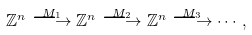<formula> <loc_0><loc_0><loc_500><loc_500>\mathbb { Z } ^ { n } \overset { M _ { 1 } } { \longrightarrow } \mathbb { Z } ^ { n } \overset { M _ { 2 } } { \longrightarrow } \mathbb { Z } ^ { n } \overset { M _ { 3 } } { \longrightarrow } \cdots ,</formula> 